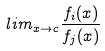Convert formula to latex. <formula><loc_0><loc_0><loc_500><loc_500>l i m _ { x \rightarrow c } \frac { f _ { i } ( x ) } { f _ { j } ( x ) }</formula> 